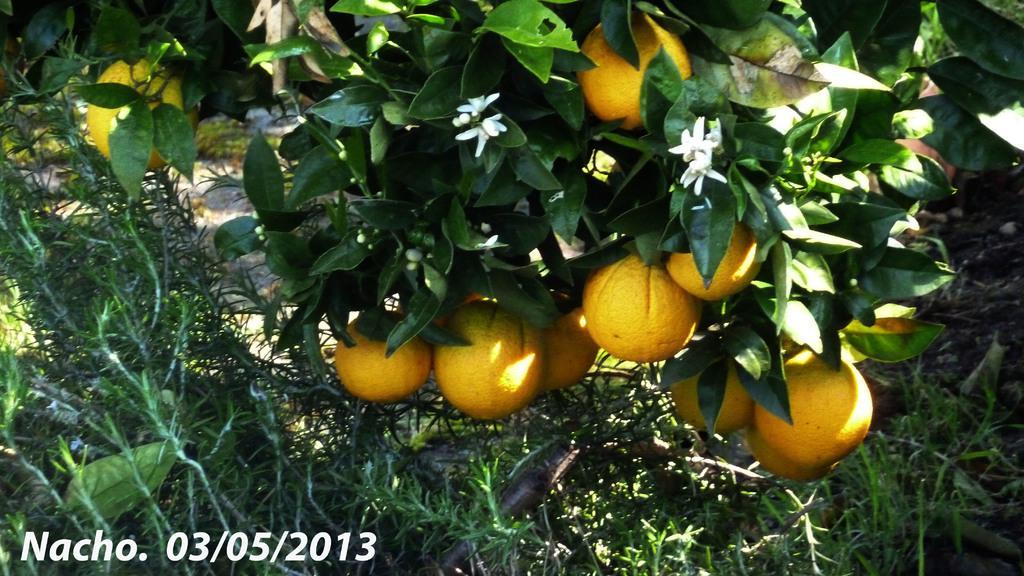How would you summarize this image in a sentence or two? In this image I can see few fruits to the trees. Fruits are in yellow color. I can see few plants in green color. 